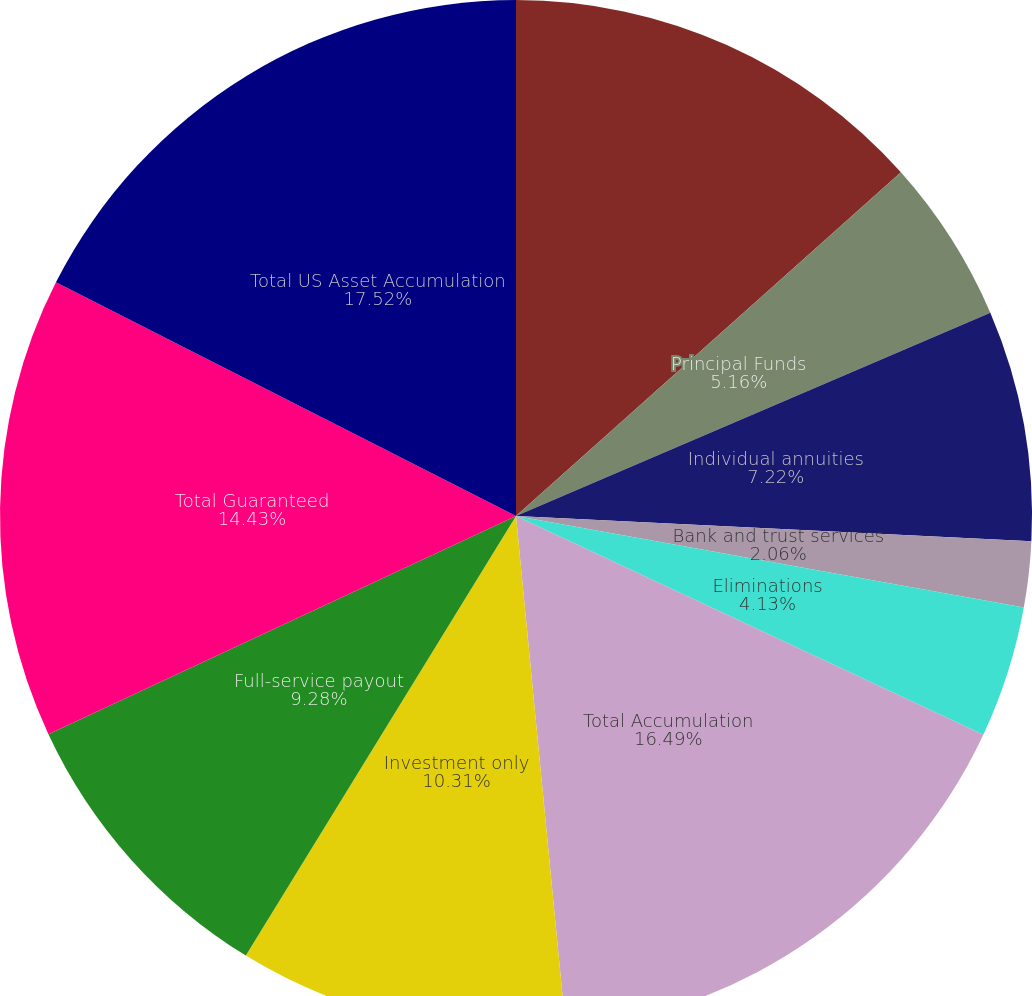Convert chart. <chart><loc_0><loc_0><loc_500><loc_500><pie_chart><fcel>Full-service accumulation<fcel>Principal Funds<fcel>Individual annuities<fcel>Bank and trust services<fcel>Eliminations<fcel>Total Accumulation<fcel>Investment only<fcel>Full-service payout<fcel>Total Guaranteed<fcel>Total US Asset Accumulation<nl><fcel>13.4%<fcel>5.16%<fcel>7.22%<fcel>2.06%<fcel>4.13%<fcel>16.49%<fcel>10.31%<fcel>9.28%<fcel>14.43%<fcel>17.52%<nl></chart> 